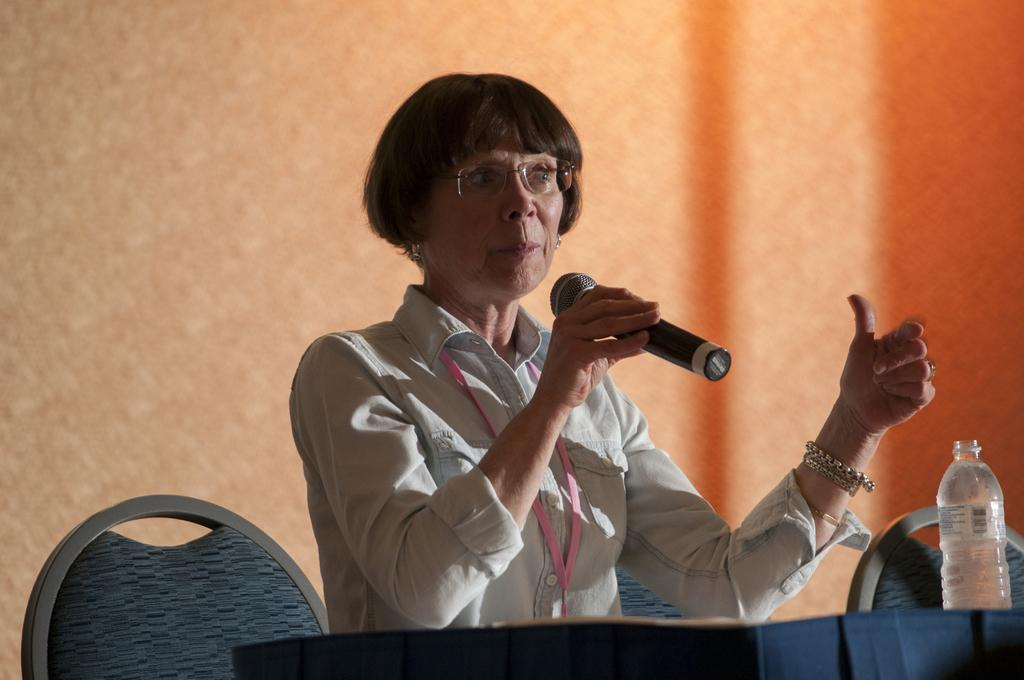Who is the main subject in the image? There is a woman in the image. What is the woman doing in the image? The woman is talking on a mic. What is the woman's position in the image? The woman is sitting on a chair. Where is the chair located in the image? The chair is at a table. What can be seen on the right side of the image? There is a bottle on the right side of the image. What type of plantation can be seen in the background of the image? There is no plantation visible in the image. How many bubbles are floating around the woman in the image? There are no bubbles present in the image. 